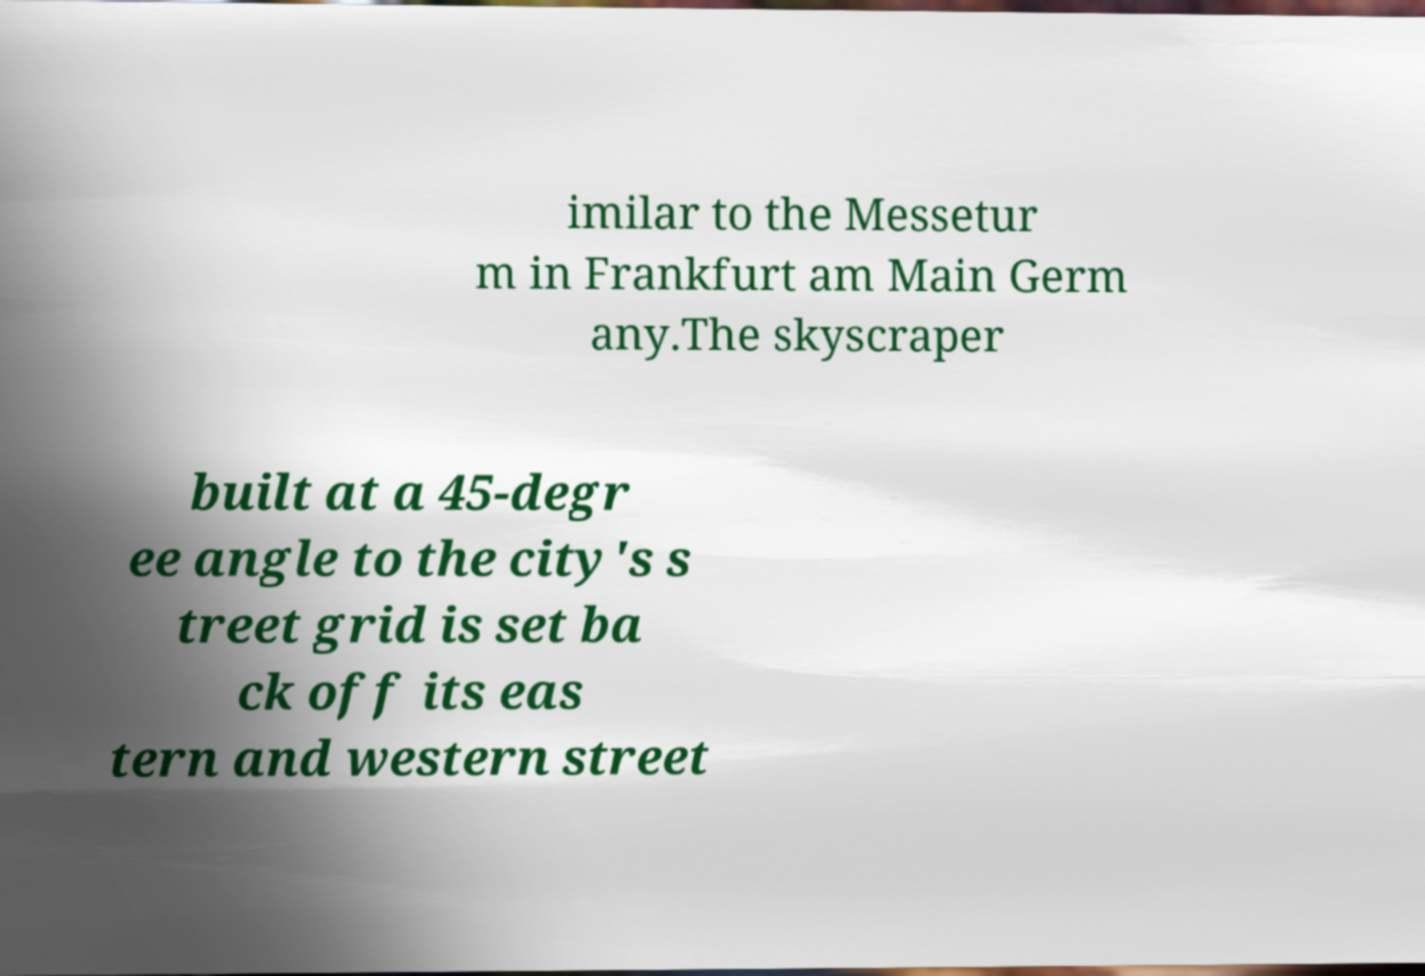Please identify and transcribe the text found in this image. imilar to the Messetur m in Frankfurt am Main Germ any.The skyscraper built at a 45-degr ee angle to the city's s treet grid is set ba ck off its eas tern and western street 